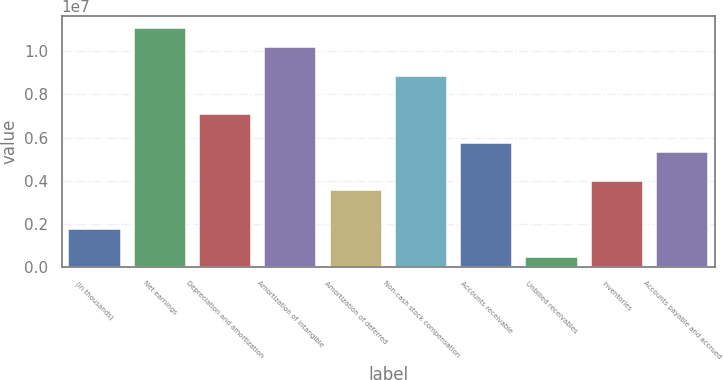<chart> <loc_0><loc_0><loc_500><loc_500><bar_chart><fcel>(in thousands)<fcel>Net earnings<fcel>Depreciation and amortization<fcel>Amortization of intangible<fcel>Amortization of deferred<fcel>Non-cash stock compensation<fcel>Accounts receivable<fcel>Unbilled receivables<fcel>Inventories<fcel>Accounts payable and accrued<nl><fcel>1.77376e+06<fcel>1.10814e+07<fcel>7.09241e+06<fcel>1.0195e+07<fcel>3.54664e+06<fcel>8.8653e+06<fcel>5.76275e+06<fcel>444092<fcel>3.98986e+06<fcel>5.31953e+06<nl></chart> 